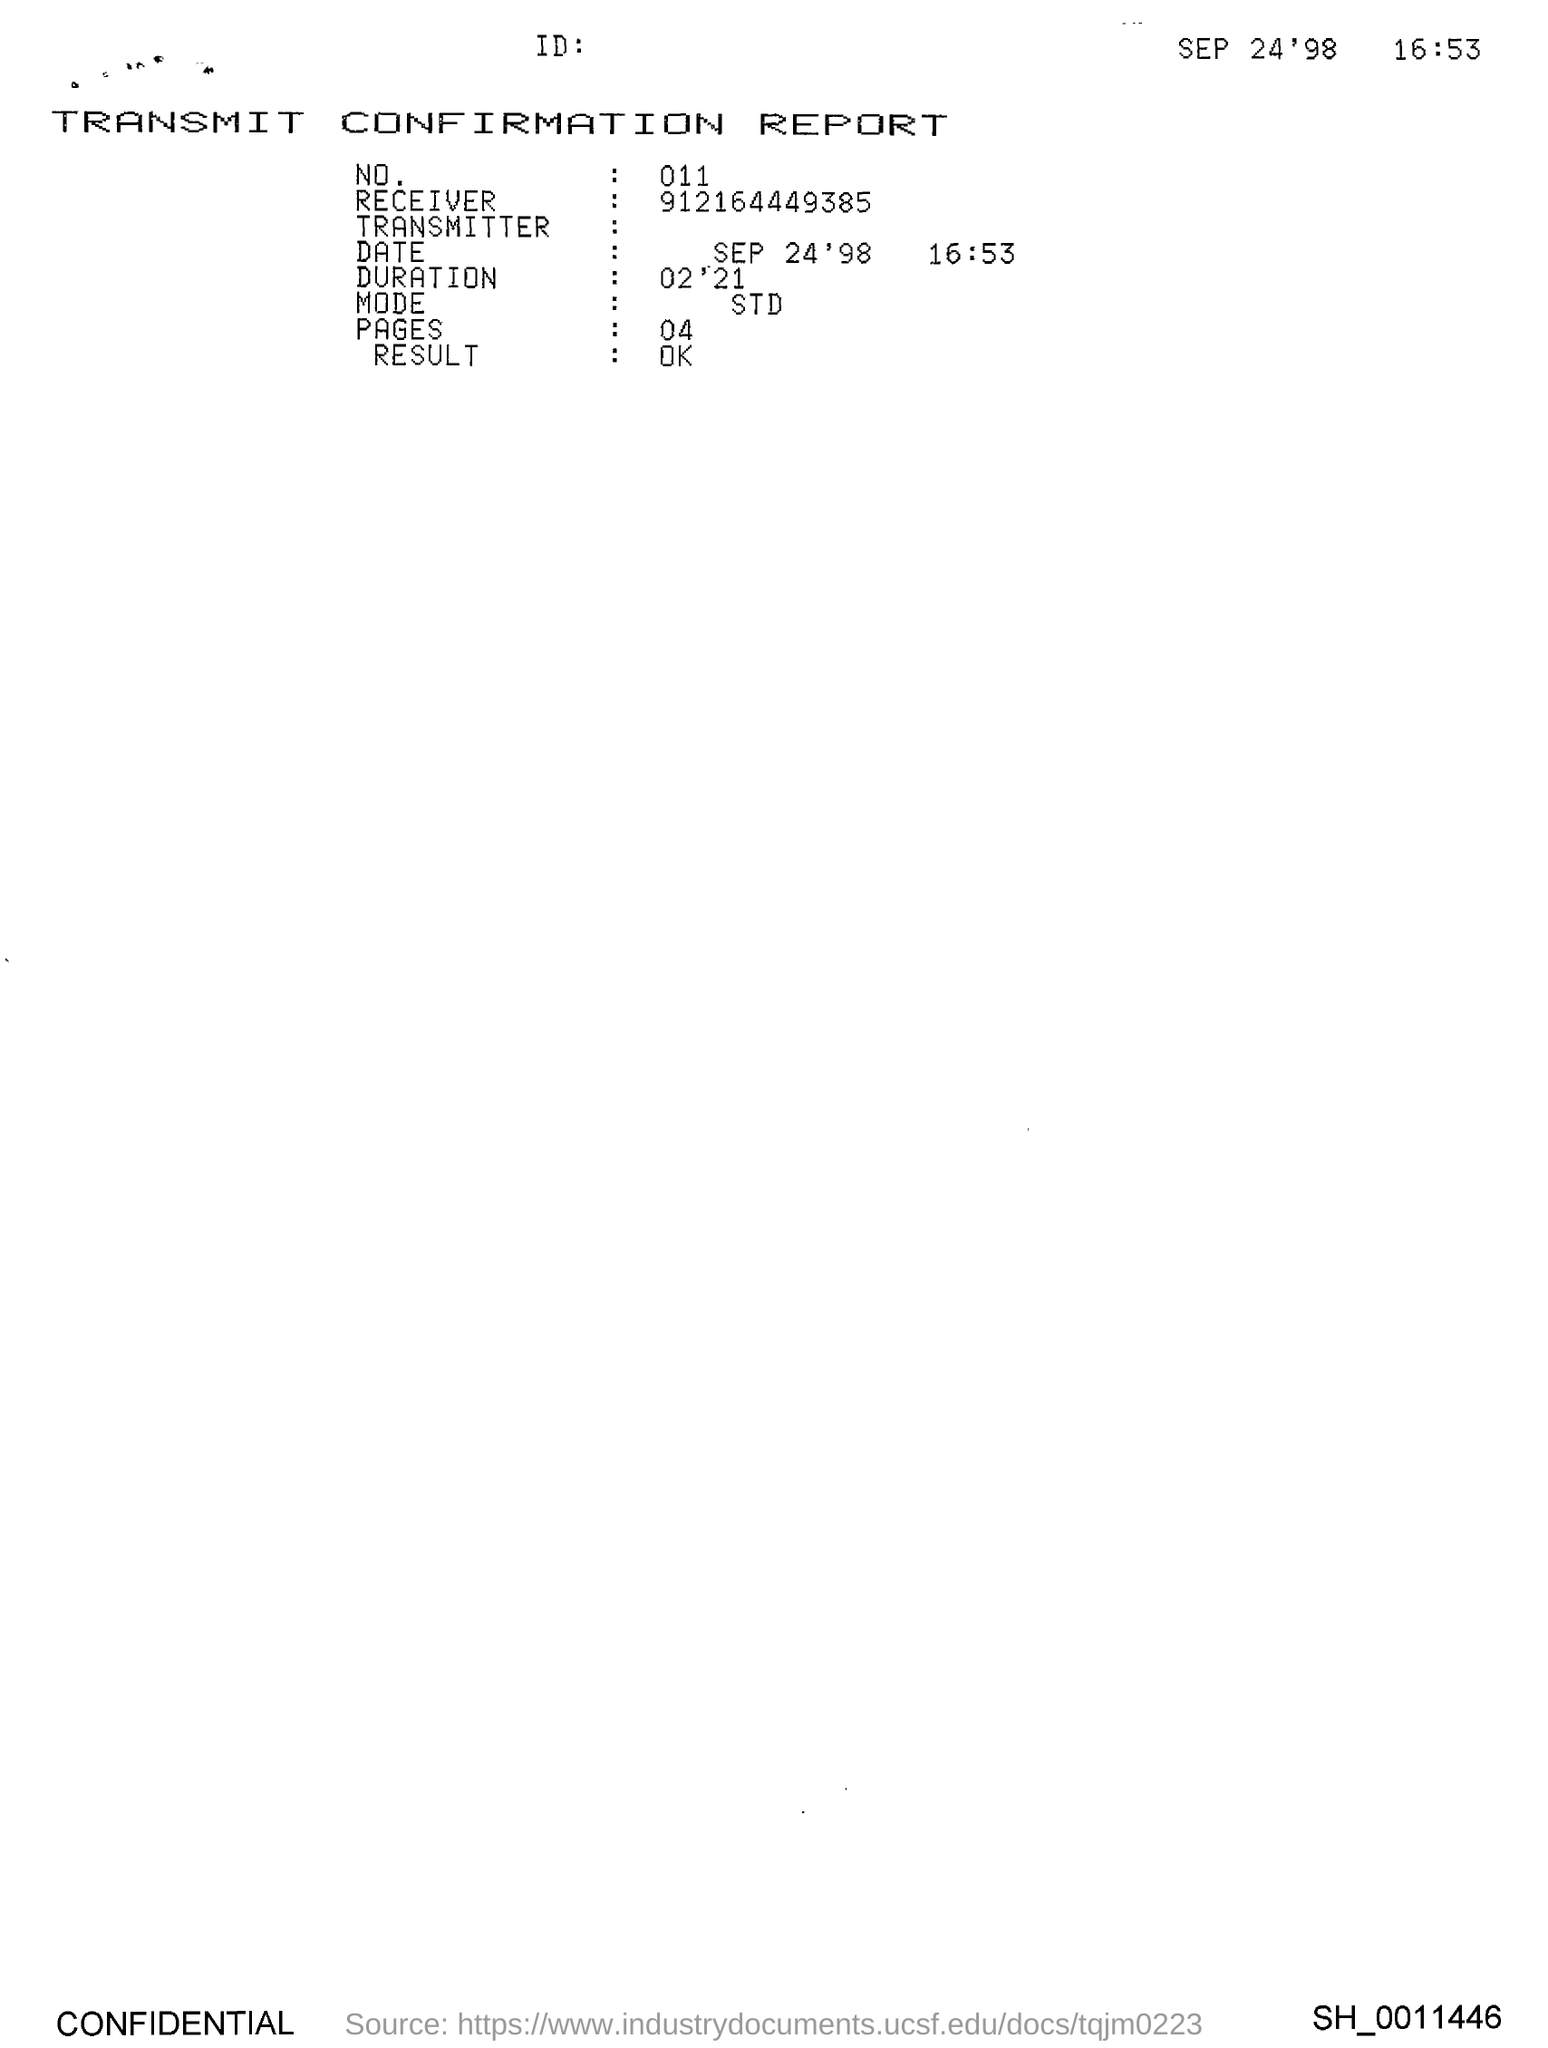What is the Title of the document?
Your answer should be compact. Transmit Confirmation Report. What is the No.?
Your answer should be very brief. 011. What is the Receiver?
Keep it short and to the point. 912164449385. What is the Mode?
Keep it short and to the point. STD. What are the pages?
Offer a very short reply. 04. What is the Result?
Keep it short and to the point. OK. 